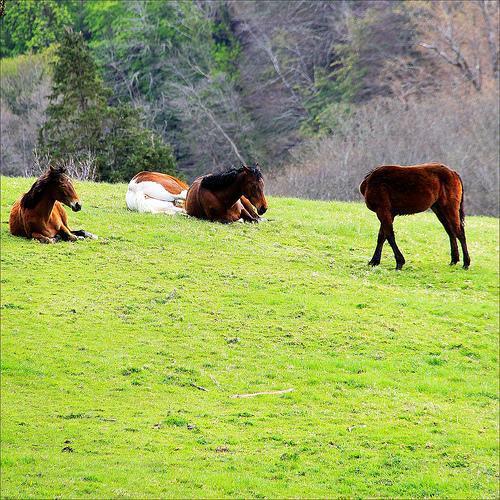How many horses are there in total?
Give a very brief answer. 4. How many horses are lying down?
Give a very brief answer. 3. How many horses are white and brown?
Give a very brief answer. 1. 